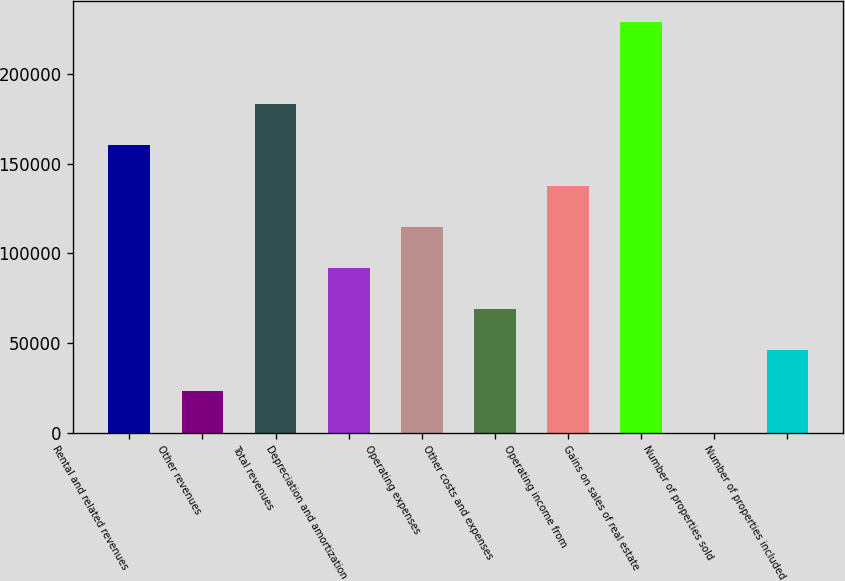Convert chart to OTSL. <chart><loc_0><loc_0><loc_500><loc_500><bar_chart><fcel>Rental and related revenues<fcel>Other revenues<fcel>Total revenues<fcel>Depreciation and amortization<fcel>Operating expenses<fcel>Other costs and expenses<fcel>Operating income from<fcel>Gains on sales of real estate<fcel>Number of properties sold<fcel>Number of properties included<nl><fcel>160448<fcel>22964.8<fcel>183361<fcel>91706.2<fcel>114620<fcel>68792.4<fcel>137534<fcel>229189<fcel>51<fcel>45878.6<nl></chart> 